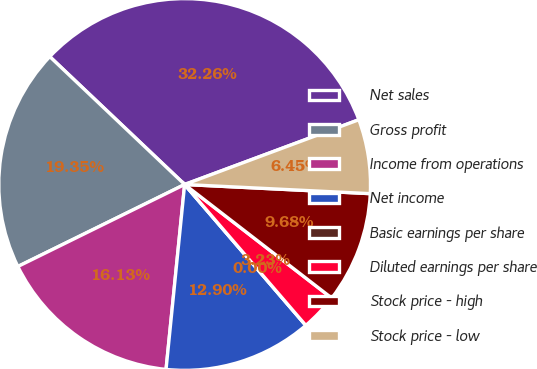Convert chart. <chart><loc_0><loc_0><loc_500><loc_500><pie_chart><fcel>Net sales<fcel>Gross profit<fcel>Income from operations<fcel>Net income<fcel>Basic earnings per share<fcel>Diluted earnings per share<fcel>Stock price - high<fcel>Stock price - low<nl><fcel>32.26%<fcel>19.35%<fcel>16.13%<fcel>12.9%<fcel>0.0%<fcel>3.23%<fcel>9.68%<fcel>6.45%<nl></chart> 